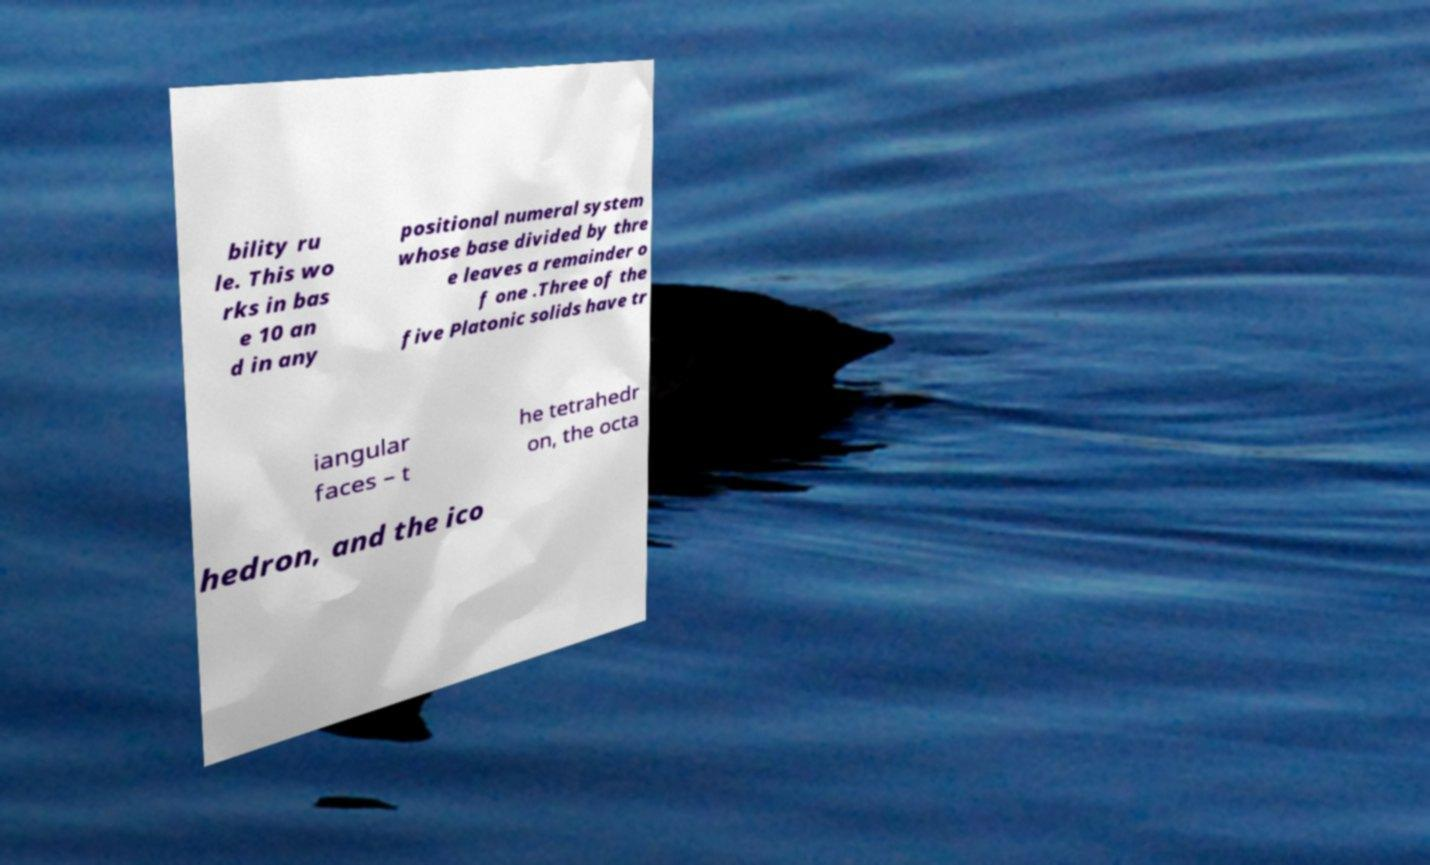What messages or text are displayed in this image? I need them in a readable, typed format. bility ru le. This wo rks in bas e 10 an d in any positional numeral system whose base divided by thre e leaves a remainder o f one .Three of the five Platonic solids have tr iangular faces – t he tetrahedr on, the octa hedron, and the ico 